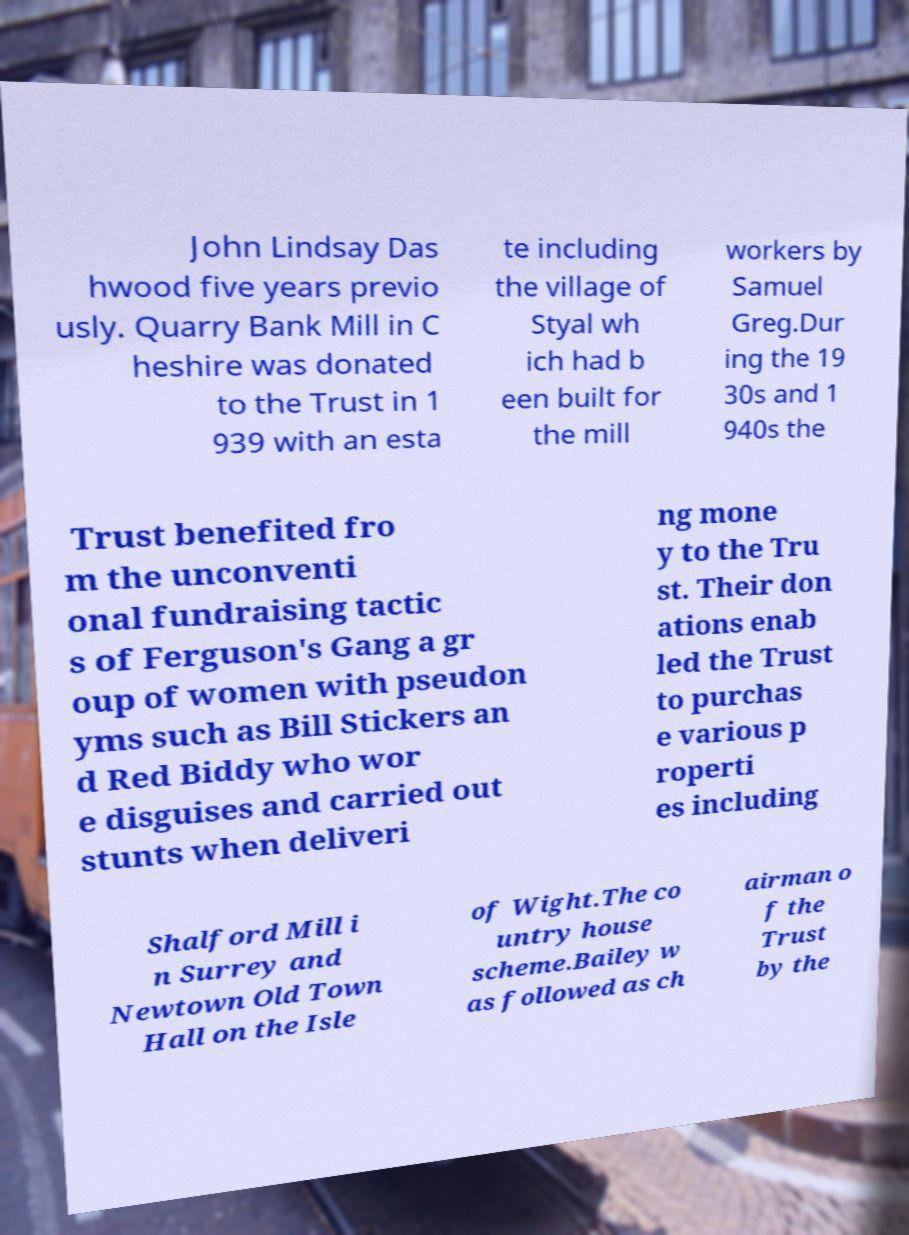I need the written content from this picture converted into text. Can you do that? John Lindsay Das hwood five years previo usly. Quarry Bank Mill in C heshire was donated to the Trust in 1 939 with an esta te including the village of Styal wh ich had b een built for the mill workers by Samuel Greg.Dur ing the 19 30s and 1 940s the Trust benefited fro m the unconventi onal fundraising tactic s of Ferguson's Gang a gr oup of women with pseudon yms such as Bill Stickers an d Red Biddy who wor e disguises and carried out stunts when deliveri ng mone y to the Tru st. Their don ations enab led the Trust to purchas e various p roperti es including Shalford Mill i n Surrey and Newtown Old Town Hall on the Isle of Wight.The co untry house scheme.Bailey w as followed as ch airman o f the Trust by the 